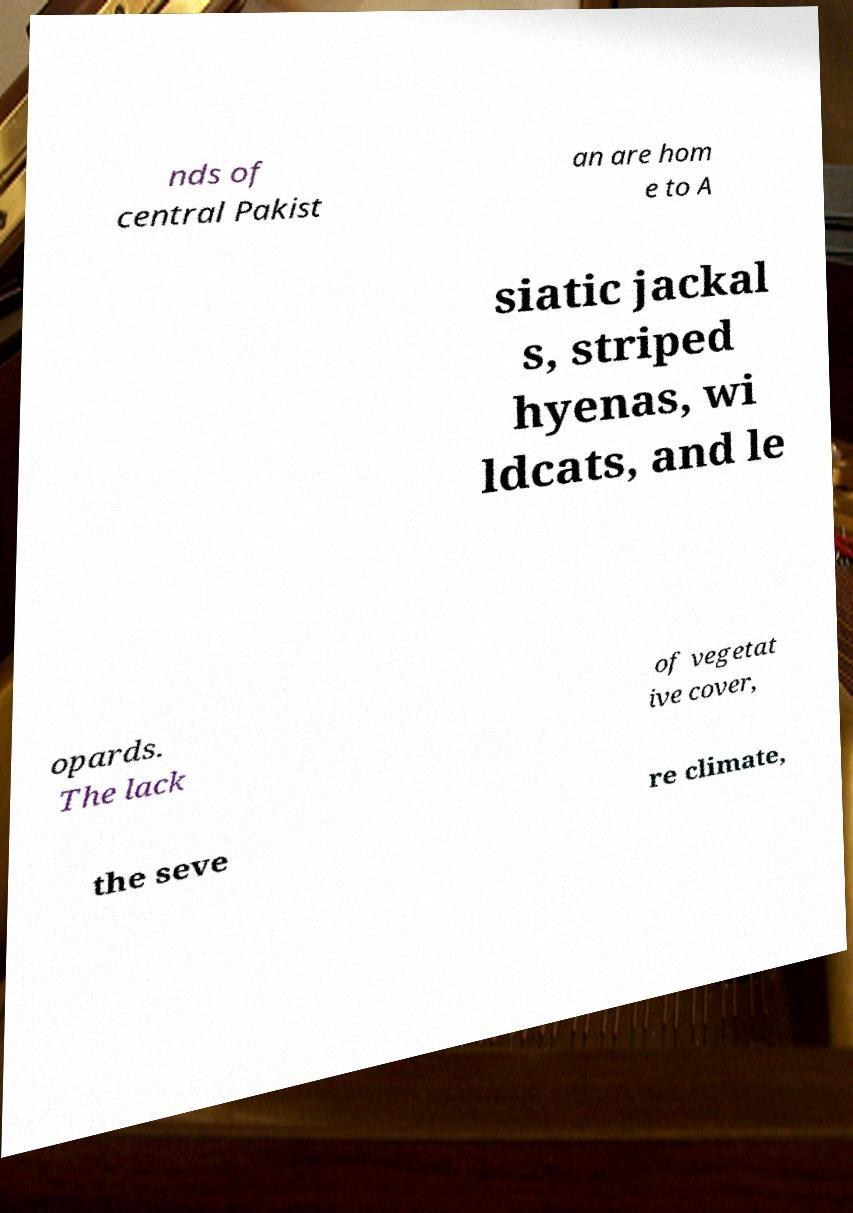What messages or text are displayed in this image? I need them in a readable, typed format. nds of central Pakist an are hom e to A siatic jackal s, striped hyenas, wi ldcats, and le opards. The lack of vegetat ive cover, the seve re climate, 